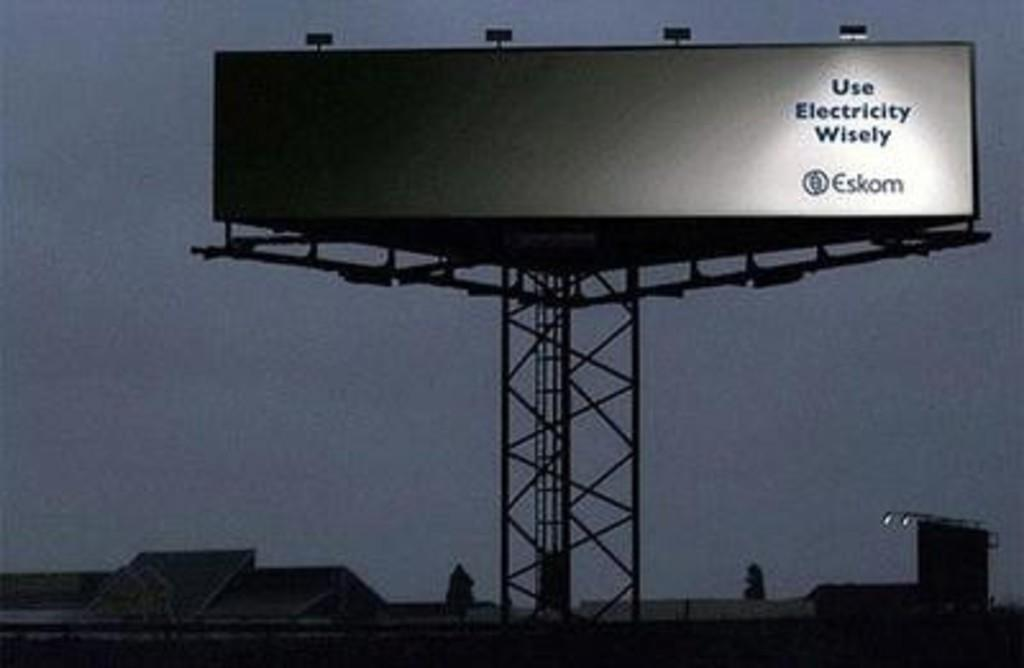Provide a one-sentence caption for the provided image. A BILLBOARD THAT SAYS "USE ELECTRICITY WISELY" BY THE COMPANY ESKOM. 